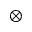<formula> <loc_0><loc_0><loc_500><loc_500>\otimes</formula> 